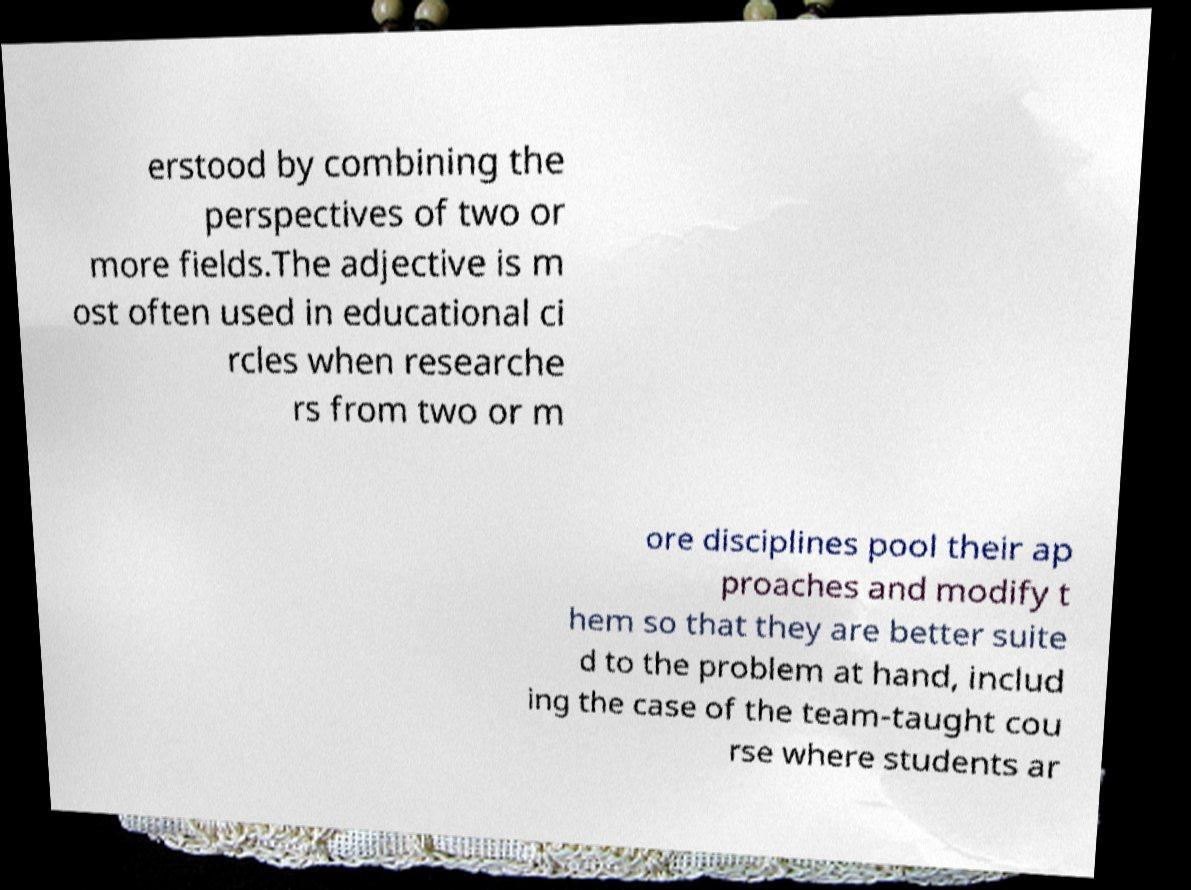I need the written content from this picture converted into text. Can you do that? erstood by combining the perspectives of two or more fields.The adjective is m ost often used in educational ci rcles when researche rs from two or m ore disciplines pool their ap proaches and modify t hem so that they are better suite d to the problem at hand, includ ing the case of the team-taught cou rse where students ar 